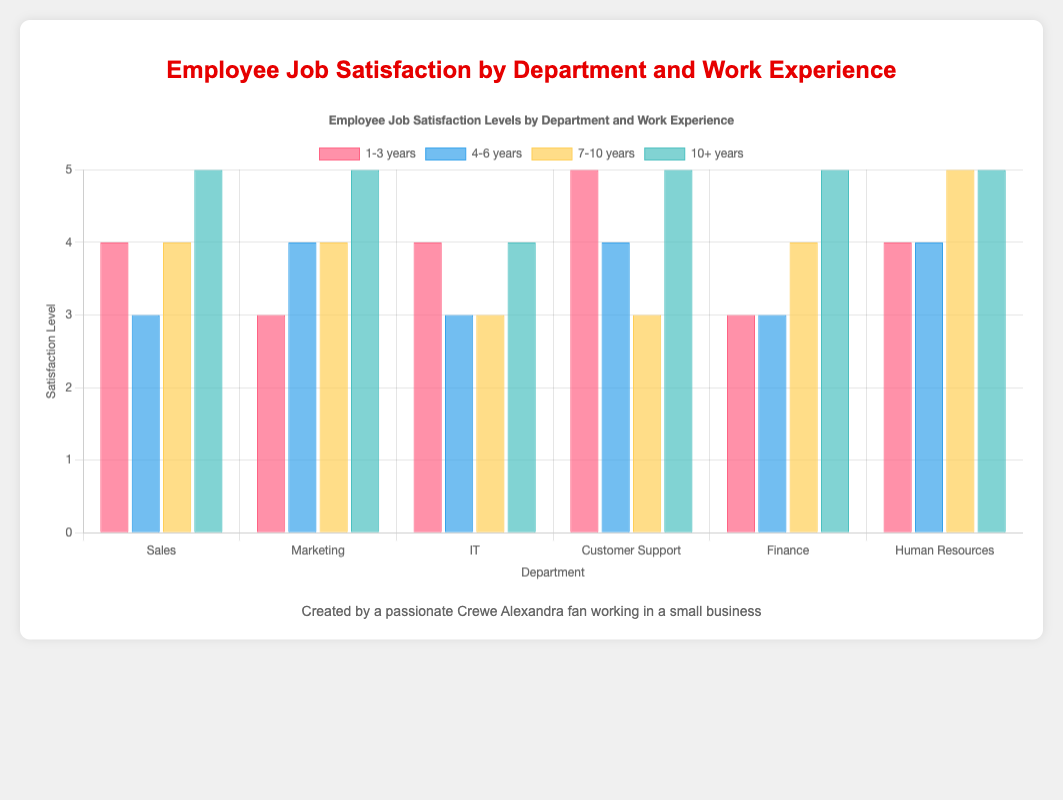What's the average satisfaction level in the Sales department? The satisfaction levels in the Sales department are 4, 3, 4, and 5. Adding these together gives 4 + 3 + 4 + 5 = 16. There are 4 data points, so the average satisfaction level is 16 / 4 = 4
Answer: 4 Which department has the highest overall satisfaction level for employees with 1-3 years of experience? Look at the satisfaction levels for each department with 1-3 years of experience. Sales: 4, Marketing: 3, IT: 4, Customer Support: 5, Finance: 3, Human Resources: 4. The highest value is 5 in Customer Support
Answer: Customer Support How does the satisfaction level of employees with 7-10 years of experience differ between IT and Human Resources? Look at the satisfaction levels of IT and Human Resources for employees with 7-10 years of experience: IT is 3 and Human Resources is 5. The difference is 5 - 3 = 2
Answer: 2 Which work experience group has the most consistent satisfaction levels across all departments? Examine the variance or difference in satisfaction levels for each work experience group across departments. Work experiences: 1-3 years (3, 3, 4, 5, 3, 4), 4-6 years (3, 4, 3, 4, 3, 4), 7-10 years (4, 4, 3, 3, 4, 5), 10+ years (5, 5, 4, 5, 5, 5). The group 4-6 years shows variation of 1 (4-3=1), the smallest among others.
Answer: 4-6 years What is the total satisfaction score for the IT department across all experience levels? The satisfaction levels in the IT department are 4, 3, 3, and 4. Adding these values gives 4 + 3 + 3 + 4 = 14
Answer: 14 Which department saw the highest increase in satisfaction from the 4-6 years to the 10+ years experience group? Calculate the difference in satisfaction levels between 4-6 years and 10+ years for each department. Sales: 5-3=2, Marketing: 5-4=1, IT: 4-3=1, Customer Support: 5-4=1, Finance: 5-3=2, Human Resources: 5-4=1. Sales and Finance have the highest increase of 2 points.
Answer: Sales, Finance In which department do employees with the same experience level (4-6 years) have the highest satisfaction? The satisfaction levels for the 4-6 years experience group are Sales: 3, Marketing: 4, IT: 3, Customer Support: 4, Finance: 3, Human Resources: 4. The highest values are 4 in Marketing, Customer Support, and Human Resources.
Answer: Marketing, Customer Support, Human Resources What can you infer about the satisfaction trend in the Finance department as work experience increases? Look at the satisfaction levels in the Finance department: 1-3 years: 3, 4-6 years: 3, 7-10 years: 4, 10+ years: 5. The trend shows that satisfaction generally increases as work experience increases.
Answer: Satisfaction in Finance increases with experience 